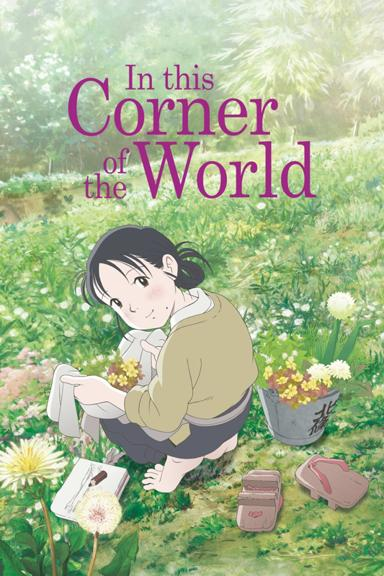Can you tell what season it might be from the vegetation and the girl's clothing? It likely is early spring. The flowers are in full bloom, which is typical of spring, and the girl's outfit, consisting of a light sweater and long pants, suggests it's cool yet comfortable weather typical of springtime. 